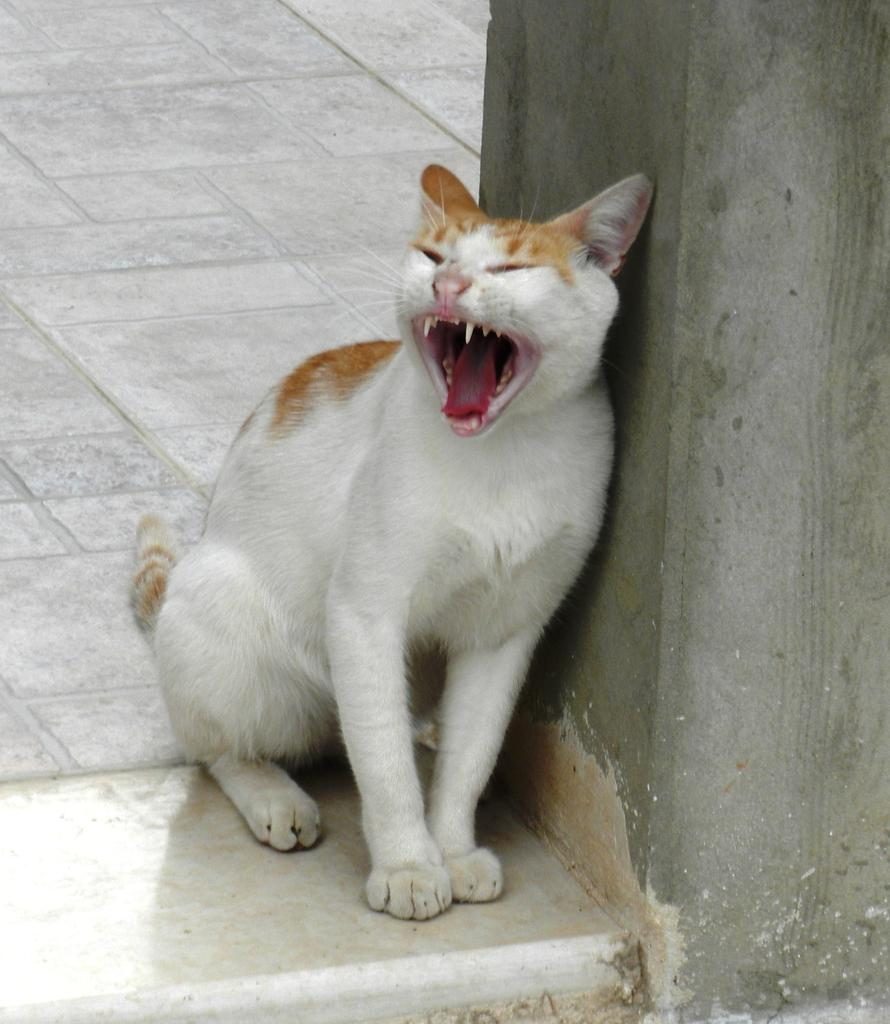What type of animal is in the picture? There is a cat in the picture. Where is the cat located in the image? The cat is sitting on the floor. Can you describe the appearance of the cat? The cat is white in color with some brown. What is the cat leaning against in the image? The cat is leaning against a wall. What color is the wall that the cat is leaning against? The wall is gray in color. Can you see a river flowing in the background of the image? There is no river visible in the image; it features a cat sitting on the floor and leaning against a wall. Is there a ring on the cat's paw in the image? There is no ring present on the cat's paw in the image. 